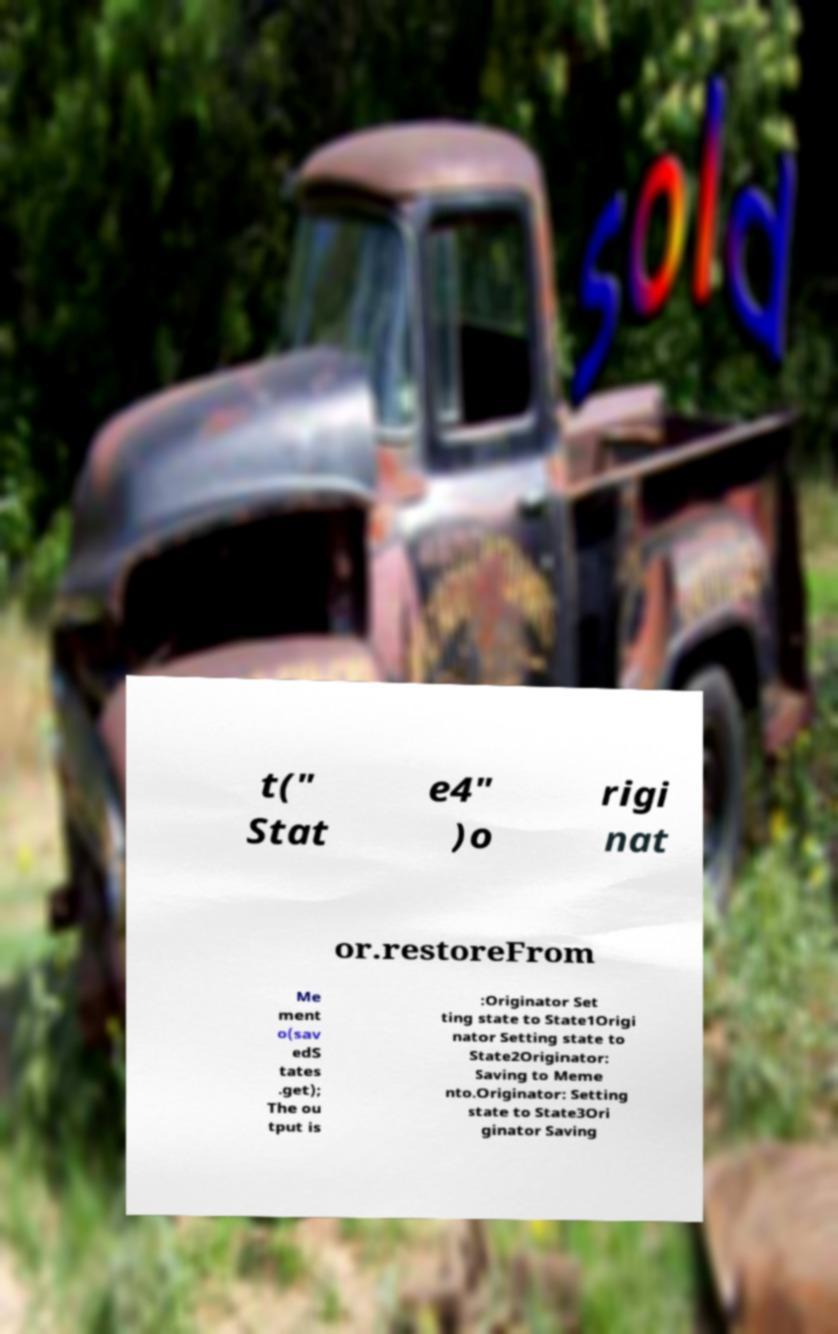Could you assist in decoding the text presented in this image and type it out clearly? t(" Stat e4" )o rigi nat or.restoreFrom Me ment o(sav edS tates .get); The ou tput is :Originator Set ting state to State1Origi nator Setting state to State2Originator: Saving to Meme nto.Originator: Setting state to State3Ori ginator Saving 